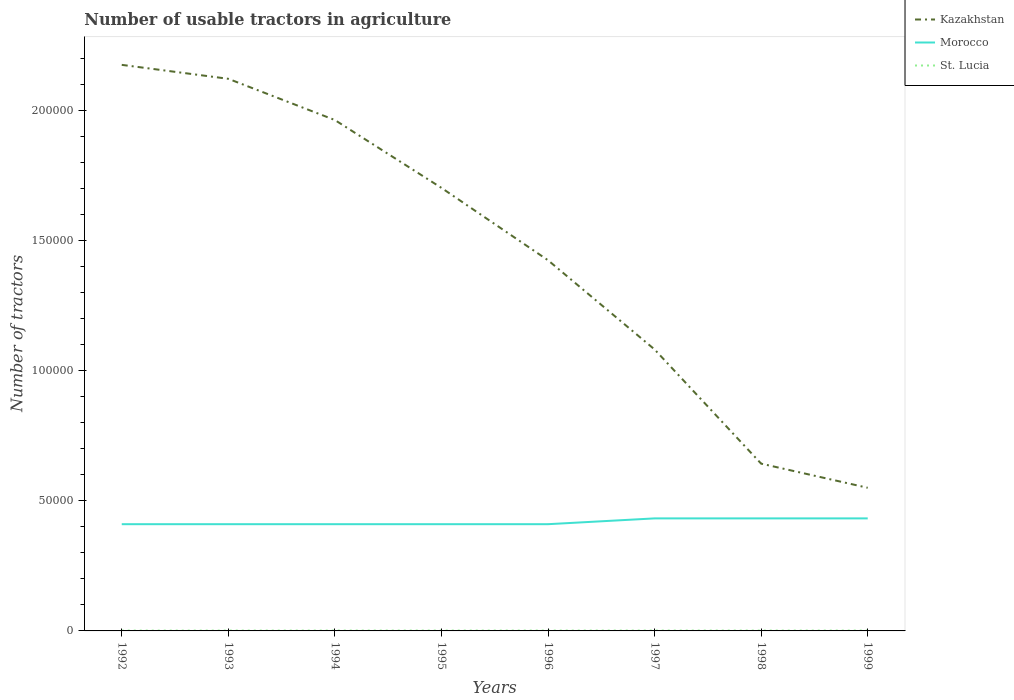Does the line corresponding to Kazakhstan intersect with the line corresponding to Morocco?
Provide a succinct answer. No. Is the number of lines equal to the number of legend labels?
Offer a very short reply. Yes. Across all years, what is the maximum number of usable tractors in agriculture in St. Lucia?
Keep it short and to the point. 130. What is the total number of usable tractors in agriculture in Kazakhstan in the graph?
Your answer should be compact. 8.81e+04. What is the difference between the highest and the second highest number of usable tractors in agriculture in Morocco?
Your response must be concise. 2226. Does the graph contain any zero values?
Ensure brevity in your answer.  No. Does the graph contain grids?
Provide a short and direct response. No. How many legend labels are there?
Provide a short and direct response. 3. How are the legend labels stacked?
Make the answer very short. Vertical. What is the title of the graph?
Provide a succinct answer. Number of usable tractors in agriculture. What is the label or title of the Y-axis?
Keep it short and to the point. Number of tractors. What is the Number of tractors of Kazakhstan in 1992?
Keep it short and to the point. 2.17e+05. What is the Number of tractors of Morocco in 1992?
Offer a terse response. 4.10e+04. What is the Number of tractors in St. Lucia in 1992?
Make the answer very short. 130. What is the Number of tractors of Kazakhstan in 1993?
Your answer should be compact. 2.12e+05. What is the Number of tractors of Morocco in 1993?
Provide a succinct answer. 4.10e+04. What is the Number of tractors in St. Lucia in 1993?
Provide a succinct answer. 135. What is the Number of tractors of Kazakhstan in 1994?
Your answer should be compact. 1.96e+05. What is the Number of tractors of Morocco in 1994?
Ensure brevity in your answer.  4.10e+04. What is the Number of tractors in St. Lucia in 1994?
Provide a short and direct response. 140. What is the Number of tractors in Kazakhstan in 1995?
Keep it short and to the point. 1.70e+05. What is the Number of tractors in Morocco in 1995?
Ensure brevity in your answer.  4.10e+04. What is the Number of tractors of St. Lucia in 1995?
Your answer should be compact. 146. What is the Number of tractors of Kazakhstan in 1996?
Your answer should be compact. 1.42e+05. What is the Number of tractors of Morocco in 1996?
Ensure brevity in your answer.  4.10e+04. What is the Number of tractors of St. Lucia in 1996?
Make the answer very short. 146. What is the Number of tractors of Kazakhstan in 1997?
Ensure brevity in your answer.  1.08e+05. What is the Number of tractors of Morocco in 1997?
Give a very brief answer. 4.32e+04. What is the Number of tractors of St. Lucia in 1997?
Offer a very short reply. 146. What is the Number of tractors in Kazakhstan in 1998?
Make the answer very short. 6.42e+04. What is the Number of tractors of Morocco in 1998?
Give a very brief answer. 4.32e+04. What is the Number of tractors of St. Lucia in 1998?
Your answer should be compact. 140. What is the Number of tractors of Kazakhstan in 1999?
Give a very brief answer. 5.50e+04. What is the Number of tractors in Morocco in 1999?
Your response must be concise. 4.32e+04. What is the Number of tractors in St. Lucia in 1999?
Ensure brevity in your answer.  138. Across all years, what is the maximum Number of tractors in Kazakhstan?
Your response must be concise. 2.17e+05. Across all years, what is the maximum Number of tractors in Morocco?
Offer a very short reply. 4.32e+04. Across all years, what is the maximum Number of tractors in St. Lucia?
Keep it short and to the point. 146. Across all years, what is the minimum Number of tractors of Kazakhstan?
Offer a very short reply. 5.50e+04. Across all years, what is the minimum Number of tractors in Morocco?
Make the answer very short. 4.10e+04. Across all years, what is the minimum Number of tractors in St. Lucia?
Make the answer very short. 130. What is the total Number of tractors in Kazakhstan in the graph?
Make the answer very short. 1.17e+06. What is the total Number of tractors in Morocco in the graph?
Offer a terse response. 3.35e+05. What is the total Number of tractors in St. Lucia in the graph?
Your response must be concise. 1121. What is the difference between the Number of tractors in Kazakhstan in 1992 and that in 1993?
Your response must be concise. 5353. What is the difference between the Number of tractors of Morocco in 1992 and that in 1993?
Provide a succinct answer. 0. What is the difference between the Number of tractors in Kazakhstan in 1992 and that in 1994?
Your answer should be very brief. 2.12e+04. What is the difference between the Number of tractors of Kazakhstan in 1992 and that in 1995?
Offer a very short reply. 4.72e+04. What is the difference between the Number of tractors in Kazakhstan in 1992 and that in 1996?
Keep it short and to the point. 7.51e+04. What is the difference between the Number of tractors of Morocco in 1992 and that in 1996?
Keep it short and to the point. 0. What is the difference between the Number of tractors of Kazakhstan in 1992 and that in 1997?
Offer a very short reply. 1.09e+05. What is the difference between the Number of tractors in Morocco in 1992 and that in 1997?
Make the answer very short. -2226. What is the difference between the Number of tractors in Kazakhstan in 1992 and that in 1998?
Keep it short and to the point. 1.53e+05. What is the difference between the Number of tractors of Morocco in 1992 and that in 1998?
Provide a succinct answer. -2226. What is the difference between the Number of tractors in St. Lucia in 1992 and that in 1998?
Keep it short and to the point. -10. What is the difference between the Number of tractors of Kazakhstan in 1992 and that in 1999?
Give a very brief answer. 1.62e+05. What is the difference between the Number of tractors of Morocco in 1992 and that in 1999?
Provide a succinct answer. -2226. What is the difference between the Number of tractors in St. Lucia in 1992 and that in 1999?
Provide a succinct answer. -8. What is the difference between the Number of tractors in Kazakhstan in 1993 and that in 1994?
Keep it short and to the point. 1.58e+04. What is the difference between the Number of tractors in Morocco in 1993 and that in 1994?
Ensure brevity in your answer.  0. What is the difference between the Number of tractors in Kazakhstan in 1993 and that in 1995?
Make the answer very short. 4.19e+04. What is the difference between the Number of tractors of Kazakhstan in 1993 and that in 1996?
Ensure brevity in your answer.  6.97e+04. What is the difference between the Number of tractors of Morocco in 1993 and that in 1996?
Provide a short and direct response. 0. What is the difference between the Number of tractors in St. Lucia in 1993 and that in 1996?
Your response must be concise. -11. What is the difference between the Number of tractors of Kazakhstan in 1993 and that in 1997?
Offer a terse response. 1.04e+05. What is the difference between the Number of tractors of Morocco in 1993 and that in 1997?
Your response must be concise. -2226. What is the difference between the Number of tractors in St. Lucia in 1993 and that in 1997?
Your response must be concise. -11. What is the difference between the Number of tractors of Kazakhstan in 1993 and that in 1998?
Make the answer very short. 1.48e+05. What is the difference between the Number of tractors of Morocco in 1993 and that in 1998?
Your answer should be compact. -2226. What is the difference between the Number of tractors of St. Lucia in 1993 and that in 1998?
Give a very brief answer. -5. What is the difference between the Number of tractors in Kazakhstan in 1993 and that in 1999?
Your response must be concise. 1.57e+05. What is the difference between the Number of tractors in Morocco in 1993 and that in 1999?
Offer a very short reply. -2226. What is the difference between the Number of tractors of St. Lucia in 1993 and that in 1999?
Ensure brevity in your answer.  -3. What is the difference between the Number of tractors in Kazakhstan in 1994 and that in 1995?
Keep it short and to the point. 2.61e+04. What is the difference between the Number of tractors in St. Lucia in 1994 and that in 1995?
Your response must be concise. -6. What is the difference between the Number of tractors in Kazakhstan in 1994 and that in 1996?
Your response must be concise. 5.39e+04. What is the difference between the Number of tractors in Kazakhstan in 1994 and that in 1997?
Offer a terse response. 8.81e+04. What is the difference between the Number of tractors in Morocco in 1994 and that in 1997?
Offer a terse response. -2226. What is the difference between the Number of tractors in St. Lucia in 1994 and that in 1997?
Give a very brief answer. -6. What is the difference between the Number of tractors of Kazakhstan in 1994 and that in 1998?
Offer a terse response. 1.32e+05. What is the difference between the Number of tractors in Morocco in 1994 and that in 1998?
Ensure brevity in your answer.  -2226. What is the difference between the Number of tractors of St. Lucia in 1994 and that in 1998?
Make the answer very short. 0. What is the difference between the Number of tractors in Kazakhstan in 1994 and that in 1999?
Give a very brief answer. 1.41e+05. What is the difference between the Number of tractors of Morocco in 1994 and that in 1999?
Provide a short and direct response. -2226. What is the difference between the Number of tractors in Kazakhstan in 1995 and that in 1996?
Ensure brevity in your answer.  2.78e+04. What is the difference between the Number of tractors of St. Lucia in 1995 and that in 1996?
Give a very brief answer. 0. What is the difference between the Number of tractors of Kazakhstan in 1995 and that in 1997?
Give a very brief answer. 6.21e+04. What is the difference between the Number of tractors of Morocco in 1995 and that in 1997?
Your response must be concise. -2226. What is the difference between the Number of tractors of St. Lucia in 1995 and that in 1997?
Give a very brief answer. 0. What is the difference between the Number of tractors in Kazakhstan in 1995 and that in 1998?
Your response must be concise. 1.06e+05. What is the difference between the Number of tractors of Morocco in 1995 and that in 1998?
Ensure brevity in your answer.  -2226. What is the difference between the Number of tractors in St. Lucia in 1995 and that in 1998?
Offer a very short reply. 6. What is the difference between the Number of tractors of Kazakhstan in 1995 and that in 1999?
Give a very brief answer. 1.15e+05. What is the difference between the Number of tractors in Morocco in 1995 and that in 1999?
Provide a succinct answer. -2226. What is the difference between the Number of tractors of St. Lucia in 1995 and that in 1999?
Provide a short and direct response. 8. What is the difference between the Number of tractors of Kazakhstan in 1996 and that in 1997?
Offer a very short reply. 3.43e+04. What is the difference between the Number of tractors in Morocco in 1996 and that in 1997?
Give a very brief answer. -2226. What is the difference between the Number of tractors in St. Lucia in 1996 and that in 1997?
Your answer should be very brief. 0. What is the difference between the Number of tractors of Kazakhstan in 1996 and that in 1998?
Your answer should be compact. 7.81e+04. What is the difference between the Number of tractors in Morocco in 1996 and that in 1998?
Make the answer very short. -2226. What is the difference between the Number of tractors in St. Lucia in 1996 and that in 1998?
Your answer should be compact. 6. What is the difference between the Number of tractors of Kazakhstan in 1996 and that in 1999?
Make the answer very short. 8.74e+04. What is the difference between the Number of tractors of Morocco in 1996 and that in 1999?
Your answer should be very brief. -2226. What is the difference between the Number of tractors of Kazakhstan in 1997 and that in 1998?
Offer a very short reply. 4.39e+04. What is the difference between the Number of tractors in St. Lucia in 1997 and that in 1998?
Give a very brief answer. 6. What is the difference between the Number of tractors of Kazakhstan in 1997 and that in 1999?
Offer a very short reply. 5.31e+04. What is the difference between the Number of tractors of Morocco in 1997 and that in 1999?
Make the answer very short. 0. What is the difference between the Number of tractors of Kazakhstan in 1998 and that in 1999?
Offer a very short reply. 9267. What is the difference between the Number of tractors of Kazakhstan in 1992 and the Number of tractors of Morocco in 1993?
Provide a succinct answer. 1.76e+05. What is the difference between the Number of tractors of Kazakhstan in 1992 and the Number of tractors of St. Lucia in 1993?
Your response must be concise. 2.17e+05. What is the difference between the Number of tractors in Morocco in 1992 and the Number of tractors in St. Lucia in 1993?
Make the answer very short. 4.09e+04. What is the difference between the Number of tractors of Kazakhstan in 1992 and the Number of tractors of Morocco in 1994?
Keep it short and to the point. 1.76e+05. What is the difference between the Number of tractors of Kazakhstan in 1992 and the Number of tractors of St. Lucia in 1994?
Offer a terse response. 2.17e+05. What is the difference between the Number of tractors in Morocco in 1992 and the Number of tractors in St. Lucia in 1994?
Your answer should be very brief. 4.09e+04. What is the difference between the Number of tractors of Kazakhstan in 1992 and the Number of tractors of Morocco in 1995?
Offer a terse response. 1.76e+05. What is the difference between the Number of tractors of Kazakhstan in 1992 and the Number of tractors of St. Lucia in 1995?
Keep it short and to the point. 2.17e+05. What is the difference between the Number of tractors in Morocco in 1992 and the Number of tractors in St. Lucia in 1995?
Keep it short and to the point. 4.09e+04. What is the difference between the Number of tractors of Kazakhstan in 1992 and the Number of tractors of Morocco in 1996?
Give a very brief answer. 1.76e+05. What is the difference between the Number of tractors of Kazakhstan in 1992 and the Number of tractors of St. Lucia in 1996?
Your answer should be compact. 2.17e+05. What is the difference between the Number of tractors of Morocco in 1992 and the Number of tractors of St. Lucia in 1996?
Your response must be concise. 4.09e+04. What is the difference between the Number of tractors of Kazakhstan in 1992 and the Number of tractors of Morocco in 1997?
Your response must be concise. 1.74e+05. What is the difference between the Number of tractors in Kazakhstan in 1992 and the Number of tractors in St. Lucia in 1997?
Provide a succinct answer. 2.17e+05. What is the difference between the Number of tractors in Morocco in 1992 and the Number of tractors in St. Lucia in 1997?
Provide a short and direct response. 4.09e+04. What is the difference between the Number of tractors of Kazakhstan in 1992 and the Number of tractors of Morocco in 1998?
Your answer should be compact. 1.74e+05. What is the difference between the Number of tractors of Kazakhstan in 1992 and the Number of tractors of St. Lucia in 1998?
Provide a short and direct response. 2.17e+05. What is the difference between the Number of tractors of Morocco in 1992 and the Number of tractors of St. Lucia in 1998?
Provide a succinct answer. 4.09e+04. What is the difference between the Number of tractors in Kazakhstan in 1992 and the Number of tractors in Morocco in 1999?
Your answer should be very brief. 1.74e+05. What is the difference between the Number of tractors of Kazakhstan in 1992 and the Number of tractors of St. Lucia in 1999?
Provide a succinct answer. 2.17e+05. What is the difference between the Number of tractors of Morocco in 1992 and the Number of tractors of St. Lucia in 1999?
Provide a succinct answer. 4.09e+04. What is the difference between the Number of tractors of Kazakhstan in 1993 and the Number of tractors of Morocco in 1994?
Give a very brief answer. 1.71e+05. What is the difference between the Number of tractors of Kazakhstan in 1993 and the Number of tractors of St. Lucia in 1994?
Your answer should be very brief. 2.12e+05. What is the difference between the Number of tractors of Morocco in 1993 and the Number of tractors of St. Lucia in 1994?
Your answer should be very brief. 4.09e+04. What is the difference between the Number of tractors of Kazakhstan in 1993 and the Number of tractors of Morocco in 1995?
Your answer should be compact. 1.71e+05. What is the difference between the Number of tractors of Kazakhstan in 1993 and the Number of tractors of St. Lucia in 1995?
Make the answer very short. 2.12e+05. What is the difference between the Number of tractors of Morocco in 1993 and the Number of tractors of St. Lucia in 1995?
Give a very brief answer. 4.09e+04. What is the difference between the Number of tractors in Kazakhstan in 1993 and the Number of tractors in Morocco in 1996?
Provide a succinct answer. 1.71e+05. What is the difference between the Number of tractors in Kazakhstan in 1993 and the Number of tractors in St. Lucia in 1996?
Your answer should be compact. 2.12e+05. What is the difference between the Number of tractors in Morocco in 1993 and the Number of tractors in St. Lucia in 1996?
Make the answer very short. 4.09e+04. What is the difference between the Number of tractors in Kazakhstan in 1993 and the Number of tractors in Morocco in 1997?
Offer a very short reply. 1.69e+05. What is the difference between the Number of tractors in Kazakhstan in 1993 and the Number of tractors in St. Lucia in 1997?
Your answer should be very brief. 2.12e+05. What is the difference between the Number of tractors of Morocco in 1993 and the Number of tractors of St. Lucia in 1997?
Provide a short and direct response. 4.09e+04. What is the difference between the Number of tractors in Kazakhstan in 1993 and the Number of tractors in Morocco in 1998?
Offer a very short reply. 1.69e+05. What is the difference between the Number of tractors of Kazakhstan in 1993 and the Number of tractors of St. Lucia in 1998?
Your response must be concise. 2.12e+05. What is the difference between the Number of tractors of Morocco in 1993 and the Number of tractors of St. Lucia in 1998?
Give a very brief answer. 4.09e+04. What is the difference between the Number of tractors of Kazakhstan in 1993 and the Number of tractors of Morocco in 1999?
Your response must be concise. 1.69e+05. What is the difference between the Number of tractors in Kazakhstan in 1993 and the Number of tractors in St. Lucia in 1999?
Provide a succinct answer. 2.12e+05. What is the difference between the Number of tractors in Morocco in 1993 and the Number of tractors in St. Lucia in 1999?
Provide a succinct answer. 4.09e+04. What is the difference between the Number of tractors in Kazakhstan in 1994 and the Number of tractors in Morocco in 1995?
Provide a succinct answer. 1.55e+05. What is the difference between the Number of tractors of Kazakhstan in 1994 and the Number of tractors of St. Lucia in 1995?
Ensure brevity in your answer.  1.96e+05. What is the difference between the Number of tractors in Morocco in 1994 and the Number of tractors in St. Lucia in 1995?
Your response must be concise. 4.09e+04. What is the difference between the Number of tractors of Kazakhstan in 1994 and the Number of tractors of Morocco in 1996?
Provide a succinct answer. 1.55e+05. What is the difference between the Number of tractors in Kazakhstan in 1994 and the Number of tractors in St. Lucia in 1996?
Make the answer very short. 1.96e+05. What is the difference between the Number of tractors in Morocco in 1994 and the Number of tractors in St. Lucia in 1996?
Keep it short and to the point. 4.09e+04. What is the difference between the Number of tractors in Kazakhstan in 1994 and the Number of tractors in Morocco in 1997?
Offer a very short reply. 1.53e+05. What is the difference between the Number of tractors in Kazakhstan in 1994 and the Number of tractors in St. Lucia in 1997?
Offer a very short reply. 1.96e+05. What is the difference between the Number of tractors in Morocco in 1994 and the Number of tractors in St. Lucia in 1997?
Your answer should be compact. 4.09e+04. What is the difference between the Number of tractors in Kazakhstan in 1994 and the Number of tractors in Morocco in 1998?
Provide a succinct answer. 1.53e+05. What is the difference between the Number of tractors in Kazakhstan in 1994 and the Number of tractors in St. Lucia in 1998?
Make the answer very short. 1.96e+05. What is the difference between the Number of tractors of Morocco in 1994 and the Number of tractors of St. Lucia in 1998?
Ensure brevity in your answer.  4.09e+04. What is the difference between the Number of tractors in Kazakhstan in 1994 and the Number of tractors in Morocco in 1999?
Provide a short and direct response. 1.53e+05. What is the difference between the Number of tractors of Kazakhstan in 1994 and the Number of tractors of St. Lucia in 1999?
Keep it short and to the point. 1.96e+05. What is the difference between the Number of tractors in Morocco in 1994 and the Number of tractors in St. Lucia in 1999?
Provide a succinct answer. 4.09e+04. What is the difference between the Number of tractors of Kazakhstan in 1995 and the Number of tractors of Morocco in 1996?
Keep it short and to the point. 1.29e+05. What is the difference between the Number of tractors of Kazakhstan in 1995 and the Number of tractors of St. Lucia in 1996?
Your response must be concise. 1.70e+05. What is the difference between the Number of tractors in Morocco in 1995 and the Number of tractors in St. Lucia in 1996?
Your response must be concise. 4.09e+04. What is the difference between the Number of tractors of Kazakhstan in 1995 and the Number of tractors of Morocco in 1997?
Your answer should be very brief. 1.27e+05. What is the difference between the Number of tractors of Kazakhstan in 1995 and the Number of tractors of St. Lucia in 1997?
Your answer should be very brief. 1.70e+05. What is the difference between the Number of tractors of Morocco in 1995 and the Number of tractors of St. Lucia in 1997?
Your response must be concise. 4.09e+04. What is the difference between the Number of tractors of Kazakhstan in 1995 and the Number of tractors of Morocco in 1998?
Your answer should be very brief. 1.27e+05. What is the difference between the Number of tractors in Kazakhstan in 1995 and the Number of tractors in St. Lucia in 1998?
Provide a short and direct response. 1.70e+05. What is the difference between the Number of tractors of Morocco in 1995 and the Number of tractors of St. Lucia in 1998?
Provide a succinct answer. 4.09e+04. What is the difference between the Number of tractors in Kazakhstan in 1995 and the Number of tractors in Morocco in 1999?
Offer a terse response. 1.27e+05. What is the difference between the Number of tractors of Kazakhstan in 1995 and the Number of tractors of St. Lucia in 1999?
Ensure brevity in your answer.  1.70e+05. What is the difference between the Number of tractors of Morocco in 1995 and the Number of tractors of St. Lucia in 1999?
Your answer should be very brief. 4.09e+04. What is the difference between the Number of tractors of Kazakhstan in 1996 and the Number of tractors of Morocco in 1997?
Offer a very short reply. 9.92e+04. What is the difference between the Number of tractors in Kazakhstan in 1996 and the Number of tractors in St. Lucia in 1997?
Ensure brevity in your answer.  1.42e+05. What is the difference between the Number of tractors of Morocco in 1996 and the Number of tractors of St. Lucia in 1997?
Offer a terse response. 4.09e+04. What is the difference between the Number of tractors of Kazakhstan in 1996 and the Number of tractors of Morocco in 1998?
Your answer should be compact. 9.92e+04. What is the difference between the Number of tractors in Kazakhstan in 1996 and the Number of tractors in St. Lucia in 1998?
Your answer should be very brief. 1.42e+05. What is the difference between the Number of tractors in Morocco in 1996 and the Number of tractors in St. Lucia in 1998?
Provide a succinct answer. 4.09e+04. What is the difference between the Number of tractors of Kazakhstan in 1996 and the Number of tractors of Morocco in 1999?
Ensure brevity in your answer.  9.92e+04. What is the difference between the Number of tractors of Kazakhstan in 1996 and the Number of tractors of St. Lucia in 1999?
Provide a succinct answer. 1.42e+05. What is the difference between the Number of tractors in Morocco in 1996 and the Number of tractors in St. Lucia in 1999?
Your response must be concise. 4.09e+04. What is the difference between the Number of tractors of Kazakhstan in 1997 and the Number of tractors of Morocco in 1998?
Ensure brevity in your answer.  6.49e+04. What is the difference between the Number of tractors of Kazakhstan in 1997 and the Number of tractors of St. Lucia in 1998?
Your answer should be very brief. 1.08e+05. What is the difference between the Number of tractors of Morocco in 1997 and the Number of tractors of St. Lucia in 1998?
Provide a succinct answer. 4.31e+04. What is the difference between the Number of tractors of Kazakhstan in 1997 and the Number of tractors of Morocco in 1999?
Offer a terse response. 6.49e+04. What is the difference between the Number of tractors in Kazakhstan in 1997 and the Number of tractors in St. Lucia in 1999?
Your response must be concise. 1.08e+05. What is the difference between the Number of tractors in Morocco in 1997 and the Number of tractors in St. Lucia in 1999?
Your answer should be compact. 4.31e+04. What is the difference between the Number of tractors in Kazakhstan in 1998 and the Number of tractors in Morocco in 1999?
Offer a very short reply. 2.10e+04. What is the difference between the Number of tractors of Kazakhstan in 1998 and the Number of tractors of St. Lucia in 1999?
Make the answer very short. 6.41e+04. What is the difference between the Number of tractors of Morocco in 1998 and the Number of tractors of St. Lucia in 1999?
Offer a very short reply. 4.31e+04. What is the average Number of tractors in Kazakhstan per year?
Provide a succinct answer. 1.46e+05. What is the average Number of tractors in Morocco per year?
Make the answer very short. 4.18e+04. What is the average Number of tractors of St. Lucia per year?
Offer a very short reply. 140.12. In the year 1992, what is the difference between the Number of tractors of Kazakhstan and Number of tractors of Morocco?
Provide a short and direct response. 1.76e+05. In the year 1992, what is the difference between the Number of tractors in Kazakhstan and Number of tractors in St. Lucia?
Your answer should be very brief. 2.17e+05. In the year 1992, what is the difference between the Number of tractors of Morocco and Number of tractors of St. Lucia?
Provide a short and direct response. 4.09e+04. In the year 1993, what is the difference between the Number of tractors of Kazakhstan and Number of tractors of Morocco?
Give a very brief answer. 1.71e+05. In the year 1993, what is the difference between the Number of tractors of Kazakhstan and Number of tractors of St. Lucia?
Keep it short and to the point. 2.12e+05. In the year 1993, what is the difference between the Number of tractors of Morocco and Number of tractors of St. Lucia?
Make the answer very short. 4.09e+04. In the year 1994, what is the difference between the Number of tractors of Kazakhstan and Number of tractors of Morocco?
Make the answer very short. 1.55e+05. In the year 1994, what is the difference between the Number of tractors of Kazakhstan and Number of tractors of St. Lucia?
Ensure brevity in your answer.  1.96e+05. In the year 1994, what is the difference between the Number of tractors of Morocco and Number of tractors of St. Lucia?
Your answer should be compact. 4.09e+04. In the year 1995, what is the difference between the Number of tractors in Kazakhstan and Number of tractors in Morocco?
Ensure brevity in your answer.  1.29e+05. In the year 1995, what is the difference between the Number of tractors in Kazakhstan and Number of tractors in St. Lucia?
Offer a terse response. 1.70e+05. In the year 1995, what is the difference between the Number of tractors of Morocco and Number of tractors of St. Lucia?
Provide a succinct answer. 4.09e+04. In the year 1996, what is the difference between the Number of tractors in Kazakhstan and Number of tractors in Morocco?
Offer a very short reply. 1.01e+05. In the year 1996, what is the difference between the Number of tractors of Kazakhstan and Number of tractors of St. Lucia?
Make the answer very short. 1.42e+05. In the year 1996, what is the difference between the Number of tractors of Morocco and Number of tractors of St. Lucia?
Provide a short and direct response. 4.09e+04. In the year 1997, what is the difference between the Number of tractors in Kazakhstan and Number of tractors in Morocco?
Your answer should be very brief. 6.49e+04. In the year 1997, what is the difference between the Number of tractors of Kazakhstan and Number of tractors of St. Lucia?
Keep it short and to the point. 1.08e+05. In the year 1997, what is the difference between the Number of tractors of Morocco and Number of tractors of St. Lucia?
Your response must be concise. 4.31e+04. In the year 1998, what is the difference between the Number of tractors in Kazakhstan and Number of tractors in Morocco?
Offer a very short reply. 2.10e+04. In the year 1998, what is the difference between the Number of tractors in Kazakhstan and Number of tractors in St. Lucia?
Offer a terse response. 6.41e+04. In the year 1998, what is the difference between the Number of tractors of Morocco and Number of tractors of St. Lucia?
Your answer should be compact. 4.31e+04. In the year 1999, what is the difference between the Number of tractors of Kazakhstan and Number of tractors of Morocco?
Ensure brevity in your answer.  1.18e+04. In the year 1999, what is the difference between the Number of tractors of Kazakhstan and Number of tractors of St. Lucia?
Your answer should be compact. 5.48e+04. In the year 1999, what is the difference between the Number of tractors of Morocco and Number of tractors of St. Lucia?
Give a very brief answer. 4.31e+04. What is the ratio of the Number of tractors of Kazakhstan in 1992 to that in 1993?
Provide a succinct answer. 1.03. What is the ratio of the Number of tractors of Morocco in 1992 to that in 1993?
Ensure brevity in your answer.  1. What is the ratio of the Number of tractors of St. Lucia in 1992 to that in 1993?
Keep it short and to the point. 0.96. What is the ratio of the Number of tractors of Kazakhstan in 1992 to that in 1994?
Your answer should be very brief. 1.11. What is the ratio of the Number of tractors in Morocco in 1992 to that in 1994?
Your answer should be compact. 1. What is the ratio of the Number of tractors of St. Lucia in 1992 to that in 1994?
Offer a very short reply. 0.93. What is the ratio of the Number of tractors of Kazakhstan in 1992 to that in 1995?
Offer a very short reply. 1.28. What is the ratio of the Number of tractors in St. Lucia in 1992 to that in 1995?
Your answer should be very brief. 0.89. What is the ratio of the Number of tractors in Kazakhstan in 1992 to that in 1996?
Your answer should be compact. 1.53. What is the ratio of the Number of tractors of Morocco in 1992 to that in 1996?
Provide a succinct answer. 1. What is the ratio of the Number of tractors in St. Lucia in 1992 to that in 1996?
Give a very brief answer. 0.89. What is the ratio of the Number of tractors of Kazakhstan in 1992 to that in 1997?
Provide a short and direct response. 2.01. What is the ratio of the Number of tractors of Morocco in 1992 to that in 1997?
Your answer should be very brief. 0.95. What is the ratio of the Number of tractors of St. Lucia in 1992 to that in 1997?
Provide a short and direct response. 0.89. What is the ratio of the Number of tractors of Kazakhstan in 1992 to that in 1998?
Offer a terse response. 3.38. What is the ratio of the Number of tractors in Morocco in 1992 to that in 1998?
Your answer should be very brief. 0.95. What is the ratio of the Number of tractors in St. Lucia in 1992 to that in 1998?
Keep it short and to the point. 0.93. What is the ratio of the Number of tractors in Kazakhstan in 1992 to that in 1999?
Give a very brief answer. 3.95. What is the ratio of the Number of tractors in Morocco in 1992 to that in 1999?
Provide a succinct answer. 0.95. What is the ratio of the Number of tractors of St. Lucia in 1992 to that in 1999?
Provide a short and direct response. 0.94. What is the ratio of the Number of tractors of Kazakhstan in 1993 to that in 1994?
Your answer should be compact. 1.08. What is the ratio of the Number of tractors of Morocco in 1993 to that in 1994?
Your answer should be compact. 1. What is the ratio of the Number of tractors of Kazakhstan in 1993 to that in 1995?
Give a very brief answer. 1.25. What is the ratio of the Number of tractors in Morocco in 1993 to that in 1995?
Provide a succinct answer. 1. What is the ratio of the Number of tractors in St. Lucia in 1993 to that in 1995?
Ensure brevity in your answer.  0.92. What is the ratio of the Number of tractors in Kazakhstan in 1993 to that in 1996?
Offer a terse response. 1.49. What is the ratio of the Number of tractors of Morocco in 1993 to that in 1996?
Give a very brief answer. 1. What is the ratio of the Number of tractors of St. Lucia in 1993 to that in 1996?
Provide a short and direct response. 0.92. What is the ratio of the Number of tractors of Kazakhstan in 1993 to that in 1997?
Make the answer very short. 1.96. What is the ratio of the Number of tractors in Morocco in 1993 to that in 1997?
Make the answer very short. 0.95. What is the ratio of the Number of tractors in St. Lucia in 1993 to that in 1997?
Provide a short and direct response. 0.92. What is the ratio of the Number of tractors of Kazakhstan in 1993 to that in 1998?
Offer a terse response. 3.3. What is the ratio of the Number of tractors in Morocco in 1993 to that in 1998?
Offer a terse response. 0.95. What is the ratio of the Number of tractors in Kazakhstan in 1993 to that in 1999?
Your answer should be very brief. 3.86. What is the ratio of the Number of tractors of Morocco in 1993 to that in 1999?
Ensure brevity in your answer.  0.95. What is the ratio of the Number of tractors of St. Lucia in 1993 to that in 1999?
Provide a short and direct response. 0.98. What is the ratio of the Number of tractors in Kazakhstan in 1994 to that in 1995?
Offer a very short reply. 1.15. What is the ratio of the Number of tractors in Morocco in 1994 to that in 1995?
Give a very brief answer. 1. What is the ratio of the Number of tractors in St. Lucia in 1994 to that in 1995?
Keep it short and to the point. 0.96. What is the ratio of the Number of tractors in Kazakhstan in 1994 to that in 1996?
Give a very brief answer. 1.38. What is the ratio of the Number of tractors of Morocco in 1994 to that in 1996?
Offer a very short reply. 1. What is the ratio of the Number of tractors in St. Lucia in 1994 to that in 1996?
Keep it short and to the point. 0.96. What is the ratio of the Number of tractors in Kazakhstan in 1994 to that in 1997?
Provide a succinct answer. 1.81. What is the ratio of the Number of tractors in Morocco in 1994 to that in 1997?
Provide a succinct answer. 0.95. What is the ratio of the Number of tractors in St. Lucia in 1994 to that in 1997?
Keep it short and to the point. 0.96. What is the ratio of the Number of tractors of Kazakhstan in 1994 to that in 1998?
Give a very brief answer. 3.05. What is the ratio of the Number of tractors in Morocco in 1994 to that in 1998?
Give a very brief answer. 0.95. What is the ratio of the Number of tractors in St. Lucia in 1994 to that in 1998?
Your response must be concise. 1. What is the ratio of the Number of tractors in Kazakhstan in 1994 to that in 1999?
Keep it short and to the point. 3.57. What is the ratio of the Number of tractors in Morocco in 1994 to that in 1999?
Make the answer very short. 0.95. What is the ratio of the Number of tractors of St. Lucia in 1994 to that in 1999?
Give a very brief answer. 1.01. What is the ratio of the Number of tractors of Kazakhstan in 1995 to that in 1996?
Make the answer very short. 1.2. What is the ratio of the Number of tractors of Morocco in 1995 to that in 1996?
Your answer should be compact. 1. What is the ratio of the Number of tractors in Kazakhstan in 1995 to that in 1997?
Your answer should be compact. 1.57. What is the ratio of the Number of tractors of Morocco in 1995 to that in 1997?
Provide a short and direct response. 0.95. What is the ratio of the Number of tractors of St. Lucia in 1995 to that in 1997?
Ensure brevity in your answer.  1. What is the ratio of the Number of tractors of Kazakhstan in 1995 to that in 1998?
Your answer should be very brief. 2.65. What is the ratio of the Number of tractors of Morocco in 1995 to that in 1998?
Keep it short and to the point. 0.95. What is the ratio of the Number of tractors in St. Lucia in 1995 to that in 1998?
Provide a short and direct response. 1.04. What is the ratio of the Number of tractors in Kazakhstan in 1995 to that in 1999?
Your answer should be compact. 3.1. What is the ratio of the Number of tractors in Morocco in 1995 to that in 1999?
Make the answer very short. 0.95. What is the ratio of the Number of tractors of St. Lucia in 1995 to that in 1999?
Your response must be concise. 1.06. What is the ratio of the Number of tractors in Kazakhstan in 1996 to that in 1997?
Make the answer very short. 1.32. What is the ratio of the Number of tractors in Morocco in 1996 to that in 1997?
Your response must be concise. 0.95. What is the ratio of the Number of tractors in St. Lucia in 1996 to that in 1997?
Your answer should be compact. 1. What is the ratio of the Number of tractors of Kazakhstan in 1996 to that in 1998?
Provide a short and direct response. 2.22. What is the ratio of the Number of tractors in Morocco in 1996 to that in 1998?
Offer a terse response. 0.95. What is the ratio of the Number of tractors of St. Lucia in 1996 to that in 1998?
Make the answer very short. 1.04. What is the ratio of the Number of tractors in Kazakhstan in 1996 to that in 1999?
Your response must be concise. 2.59. What is the ratio of the Number of tractors of Morocco in 1996 to that in 1999?
Your answer should be compact. 0.95. What is the ratio of the Number of tractors of St. Lucia in 1996 to that in 1999?
Make the answer very short. 1.06. What is the ratio of the Number of tractors of Kazakhstan in 1997 to that in 1998?
Keep it short and to the point. 1.68. What is the ratio of the Number of tractors of Morocco in 1997 to that in 1998?
Your answer should be very brief. 1. What is the ratio of the Number of tractors in St. Lucia in 1997 to that in 1998?
Give a very brief answer. 1.04. What is the ratio of the Number of tractors of Kazakhstan in 1997 to that in 1999?
Make the answer very short. 1.97. What is the ratio of the Number of tractors of St. Lucia in 1997 to that in 1999?
Make the answer very short. 1.06. What is the ratio of the Number of tractors of Kazakhstan in 1998 to that in 1999?
Your response must be concise. 1.17. What is the ratio of the Number of tractors in Morocco in 1998 to that in 1999?
Keep it short and to the point. 1. What is the ratio of the Number of tractors in St. Lucia in 1998 to that in 1999?
Provide a succinct answer. 1.01. What is the difference between the highest and the second highest Number of tractors of Kazakhstan?
Make the answer very short. 5353. What is the difference between the highest and the second highest Number of tractors of St. Lucia?
Provide a short and direct response. 0. What is the difference between the highest and the lowest Number of tractors in Kazakhstan?
Keep it short and to the point. 1.62e+05. What is the difference between the highest and the lowest Number of tractors in Morocco?
Your answer should be very brief. 2226. What is the difference between the highest and the lowest Number of tractors of St. Lucia?
Keep it short and to the point. 16. 